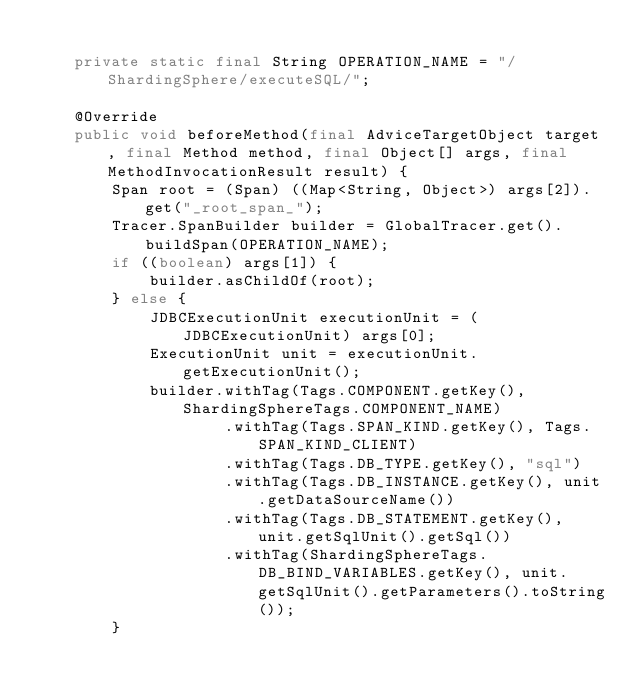<code> <loc_0><loc_0><loc_500><loc_500><_Java_>    
    private static final String OPERATION_NAME = "/ShardingSphere/executeSQL/";
    
    @Override
    public void beforeMethod(final AdviceTargetObject target, final Method method, final Object[] args, final MethodInvocationResult result) {
        Span root = (Span) ((Map<String, Object>) args[2]).get("_root_span_");
        Tracer.SpanBuilder builder = GlobalTracer.get().buildSpan(OPERATION_NAME);
        if ((boolean) args[1]) {
            builder.asChildOf(root);
        } else {
            JDBCExecutionUnit executionUnit = (JDBCExecutionUnit) args[0];
            ExecutionUnit unit = executionUnit.getExecutionUnit();
            builder.withTag(Tags.COMPONENT.getKey(), ShardingSphereTags.COMPONENT_NAME)
                    .withTag(Tags.SPAN_KIND.getKey(), Tags.SPAN_KIND_CLIENT)
                    .withTag(Tags.DB_TYPE.getKey(), "sql")
                    .withTag(Tags.DB_INSTANCE.getKey(), unit.getDataSourceName())
                    .withTag(Tags.DB_STATEMENT.getKey(), unit.getSqlUnit().getSql())
                    .withTag(ShardingSphereTags.DB_BIND_VARIABLES.getKey(), unit.getSqlUnit().getParameters().toString());
        }</code> 